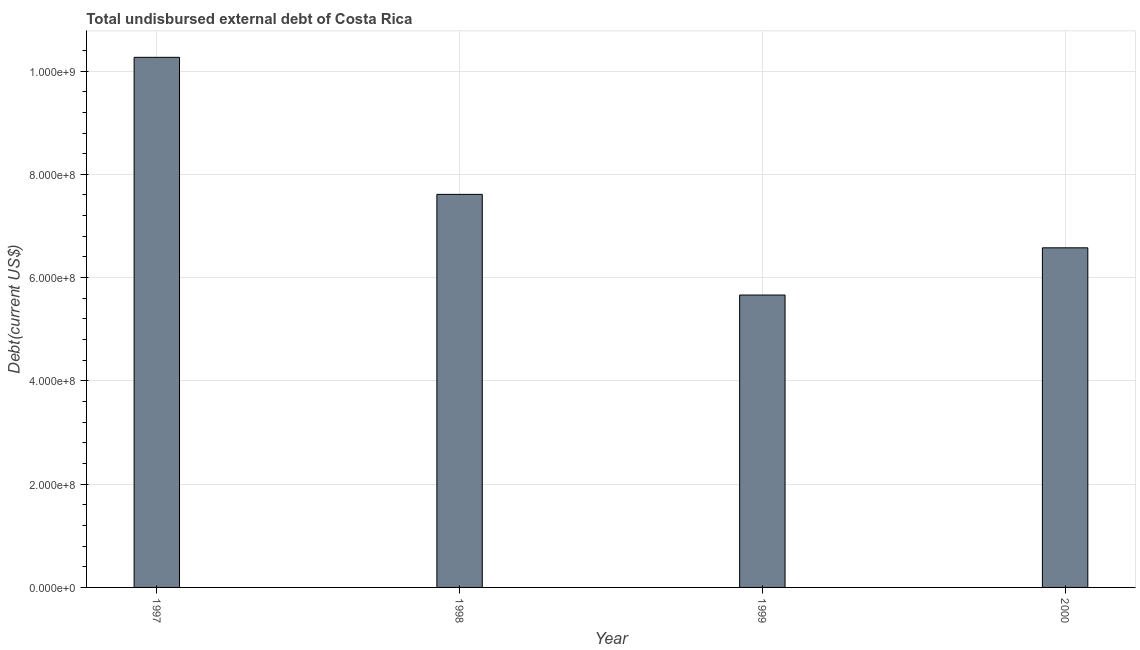What is the title of the graph?
Your answer should be very brief. Total undisbursed external debt of Costa Rica. What is the label or title of the X-axis?
Offer a very short reply. Year. What is the label or title of the Y-axis?
Offer a very short reply. Debt(current US$). What is the total debt in 1999?
Provide a short and direct response. 5.66e+08. Across all years, what is the maximum total debt?
Your response must be concise. 1.03e+09. Across all years, what is the minimum total debt?
Provide a short and direct response. 5.66e+08. In which year was the total debt maximum?
Ensure brevity in your answer.  1997. In which year was the total debt minimum?
Your answer should be compact. 1999. What is the sum of the total debt?
Offer a terse response. 3.01e+09. What is the difference between the total debt in 1999 and 2000?
Give a very brief answer. -9.14e+07. What is the average total debt per year?
Keep it short and to the point. 7.53e+08. What is the median total debt?
Provide a short and direct response. 7.09e+08. In how many years, is the total debt greater than 720000000 US$?
Your response must be concise. 2. Do a majority of the years between 2000 and 1997 (inclusive) have total debt greater than 80000000 US$?
Keep it short and to the point. Yes. What is the ratio of the total debt in 1999 to that in 2000?
Your answer should be very brief. 0.86. Is the total debt in 1997 less than that in 2000?
Offer a very short reply. No. What is the difference between the highest and the second highest total debt?
Offer a very short reply. 2.65e+08. Is the sum of the total debt in 1999 and 2000 greater than the maximum total debt across all years?
Your answer should be compact. Yes. What is the difference between the highest and the lowest total debt?
Your answer should be compact. 4.60e+08. How many bars are there?
Your answer should be compact. 4. Are all the bars in the graph horizontal?
Your response must be concise. No. How many years are there in the graph?
Offer a very short reply. 4. What is the difference between two consecutive major ticks on the Y-axis?
Ensure brevity in your answer.  2.00e+08. Are the values on the major ticks of Y-axis written in scientific E-notation?
Give a very brief answer. Yes. What is the Debt(current US$) of 1997?
Keep it short and to the point. 1.03e+09. What is the Debt(current US$) in 1998?
Offer a very short reply. 7.61e+08. What is the Debt(current US$) of 1999?
Keep it short and to the point. 5.66e+08. What is the Debt(current US$) in 2000?
Offer a very short reply. 6.58e+08. What is the difference between the Debt(current US$) in 1997 and 1998?
Make the answer very short. 2.65e+08. What is the difference between the Debt(current US$) in 1997 and 1999?
Provide a succinct answer. 4.60e+08. What is the difference between the Debt(current US$) in 1997 and 2000?
Ensure brevity in your answer.  3.69e+08. What is the difference between the Debt(current US$) in 1998 and 1999?
Offer a very short reply. 1.95e+08. What is the difference between the Debt(current US$) in 1998 and 2000?
Offer a terse response. 1.04e+08. What is the difference between the Debt(current US$) in 1999 and 2000?
Offer a very short reply. -9.14e+07. What is the ratio of the Debt(current US$) in 1997 to that in 1998?
Provide a succinct answer. 1.35. What is the ratio of the Debt(current US$) in 1997 to that in 1999?
Offer a very short reply. 1.81. What is the ratio of the Debt(current US$) in 1997 to that in 2000?
Make the answer very short. 1.56. What is the ratio of the Debt(current US$) in 1998 to that in 1999?
Provide a succinct answer. 1.34. What is the ratio of the Debt(current US$) in 1998 to that in 2000?
Provide a short and direct response. 1.16. What is the ratio of the Debt(current US$) in 1999 to that in 2000?
Offer a very short reply. 0.86. 